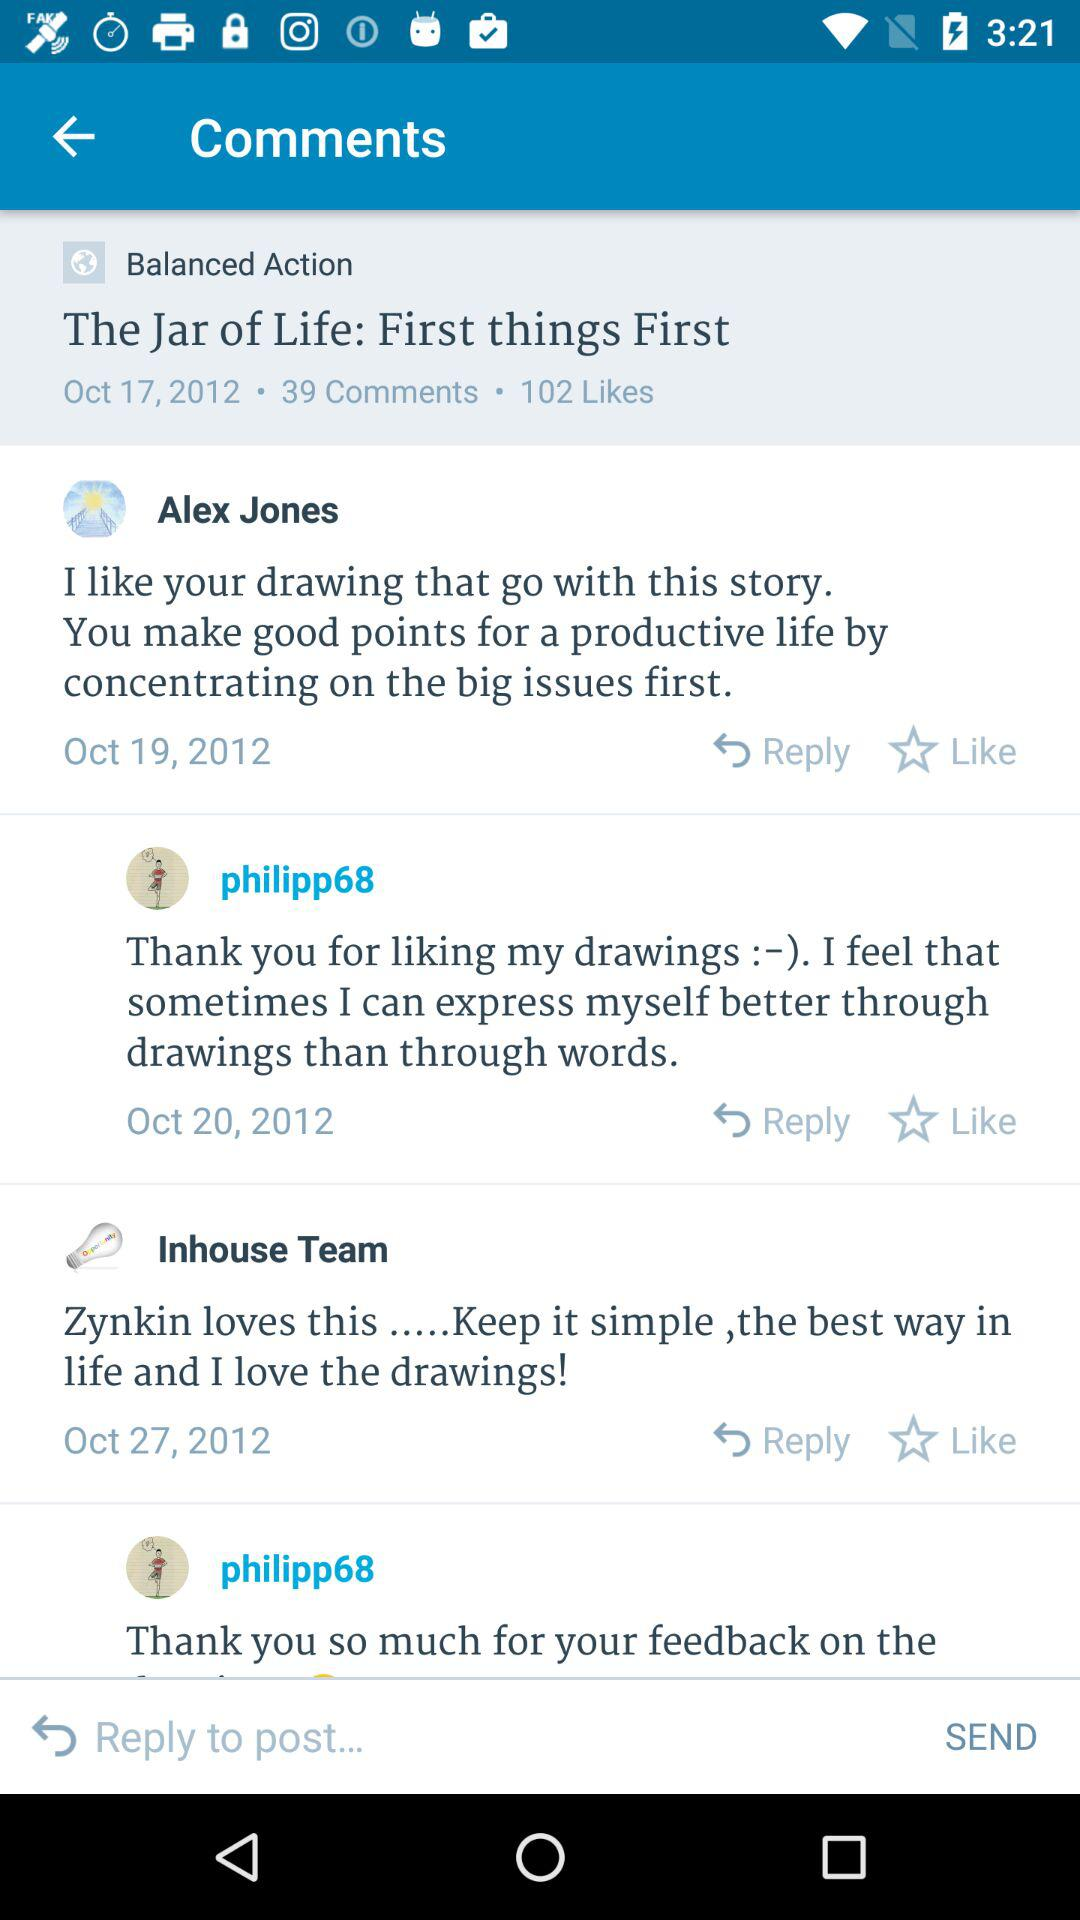How many likes were received on the "Balanced Action" post? There were 102 likes received. 